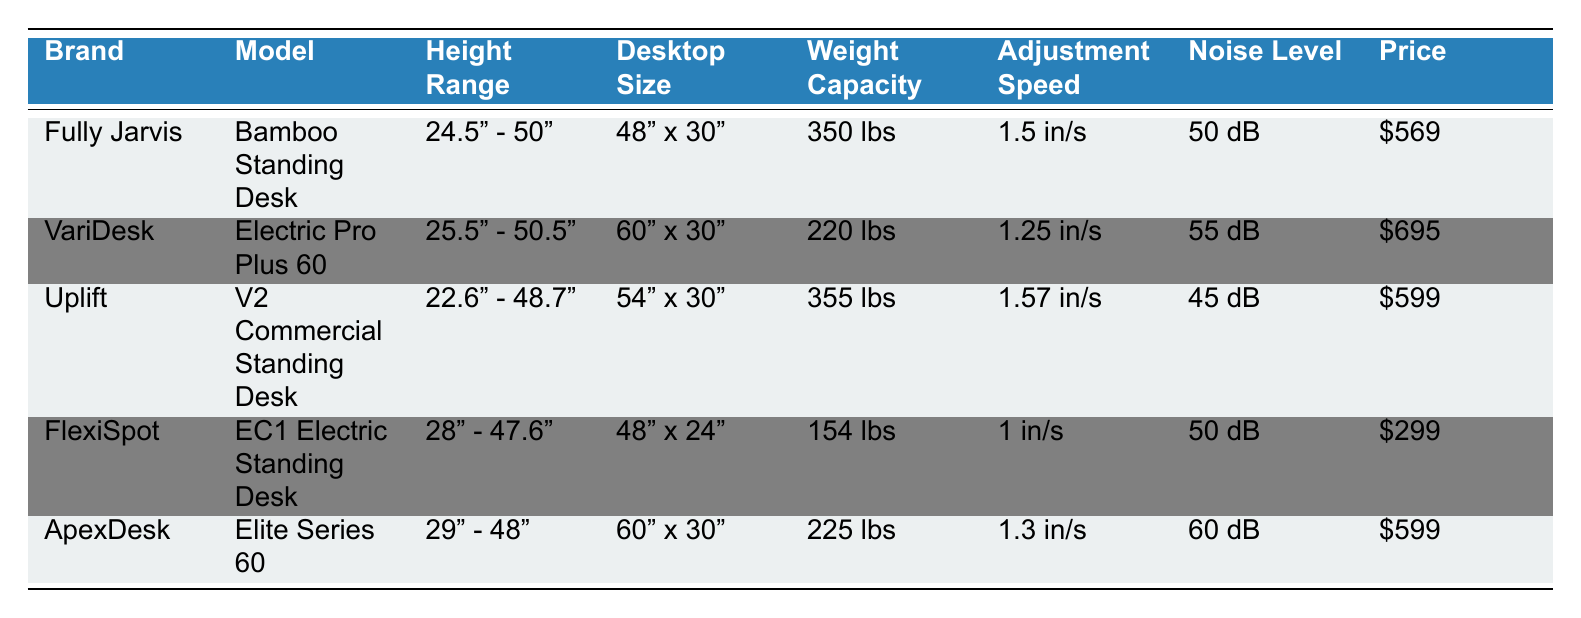What is the height range of the Uplift V2 Commercial Standing Desk? The Uplift V2 Commercial Standing Desk's row indicates its height range as 22.6" - 48.7" in the Height Range column.
Answer: 22.6" - 48.7" Which standing desk has the highest weight capacity? By comparing the Weight Capacity column of each desk, Fully Jarvis and Uplift both have the highest weight capacity, which is 350 lbs.
Answer: Fully Jarvis and Uplift (350 lbs) What is the price difference between the FlexiSpot EC1 Electric Standing Desk and the VariDesk Electric Pro Plus 60? The FlexiSpot EC1 Electric Standing Desk costs $299 and the VariDesk Electric Pro Plus 60 costs $695. Subtracting these values gives $695 - $299 = $396, which is the price difference.
Answer: $396 Is the adjustment speed of the ApexDesk Elite Series 60 faster than that of the FlexiSpot EC1 Electric Standing Desk? The ApexDesk has an adjustment speed of 1.3 inches per second, while the FlexiSpot has a speed of 1 inch per second. Since 1.3 inches per second is greater than 1 inch per second, the statement is true.
Answer: Yes What is the average adjustment speed of the standing desks listed? To find the average, first convert each adjustment speed into a decimal: 1.5, 1.25, 1.57, 1.0, and 1.3. Then sum them: 1.5 + 1.25 + 1.57 + 1 + 1.3 = 5.62. Divide this sum by the number of desks (5): 5.62 / 5 = 1.124.
Answer: 1.124 inches per second Which desk has the lowest noise level, and what is that level? The Noise Level column shows that the Uplift V2 Commercial Standing Desk has the lowest noise level at 45 dB compared to the others.
Answer: Uplift V2 Commercial Standing Desk, 45 dB How many memory presets does the Fully Jarvis have compared to the ApexDesk Elite Series 60? The Fully Jarvis has 4 memory presets while the ApexDesk Elite Series 60 has only 4 as well. So they have the same number of memory presets.
Answer: Both have 4 memory presets Is the warranty period for the VariDesk longer than that of the FlexiSpot? The VariDesk has a warranty period of 5 years, while the FlexiSpot has a warranty of 5 years as well. Since they are the same, the statement is false.
Answer: No 